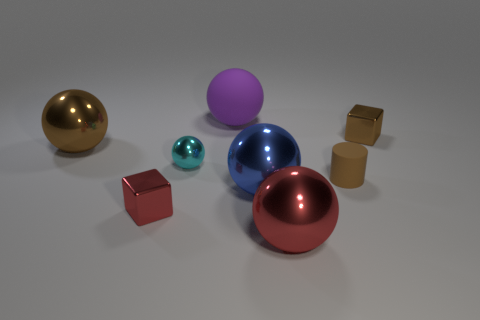How many other things are the same size as the rubber cylinder?
Provide a succinct answer. 3. Are there any tiny matte cylinders behind the tiny brown matte cylinder?
Your answer should be compact. No. Is the color of the matte cylinder the same as the rubber thing behind the small ball?
Provide a short and direct response. No. The large object behind the tiny metal block that is to the right of the matte object on the left side of the brown cylinder is what color?
Provide a short and direct response. Purple. Are there any small brown matte objects that have the same shape as the large purple object?
Offer a very short reply. No. The sphere that is the same size as the brown matte cylinder is what color?
Provide a short and direct response. Cyan. There is a big object that is on the left side of the small red object; what is it made of?
Keep it short and to the point. Metal. Does the tiny brown object that is in front of the brown metallic block have the same shape as the small metal object that is on the left side of the cyan ball?
Keep it short and to the point. No. Are there an equal number of shiny balls in front of the cylinder and brown rubber cylinders?
Your response must be concise. No. How many tiny brown blocks are the same material as the big brown ball?
Provide a short and direct response. 1. 